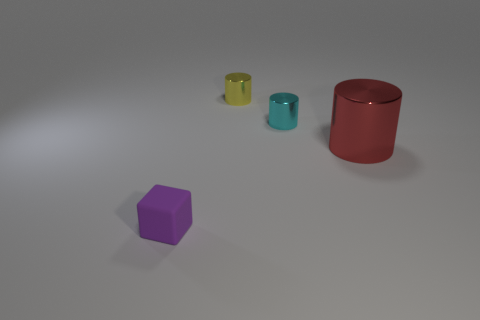What is the color of the other cylinder that is the same size as the yellow cylinder?
Provide a succinct answer. Cyan. Are there any tiny things of the same color as the small cube?
Give a very brief answer. No. What number of things are either small objects that are to the left of the small cyan cylinder or large things?
Offer a very short reply. 3. How many other things are the same size as the purple block?
Offer a terse response. 2. What material is the small cylinder that is right of the tiny cylinder that is left of the tiny cyan shiny cylinder that is right of the yellow metallic cylinder?
Make the answer very short. Metal. What number of cylinders are small yellow shiny things or red shiny things?
Ensure brevity in your answer.  2. Are there any other things that are the same shape as the small cyan object?
Your answer should be very brief. Yes. Is the number of metallic objects that are to the left of the yellow cylinder greater than the number of tiny cubes right of the small purple cube?
Offer a very short reply. No. There is a tiny shiny cylinder that is behind the cyan cylinder; how many cyan shiny objects are in front of it?
Your answer should be compact. 1. What number of objects are either big red objects or tiny cyan things?
Your answer should be very brief. 2. 